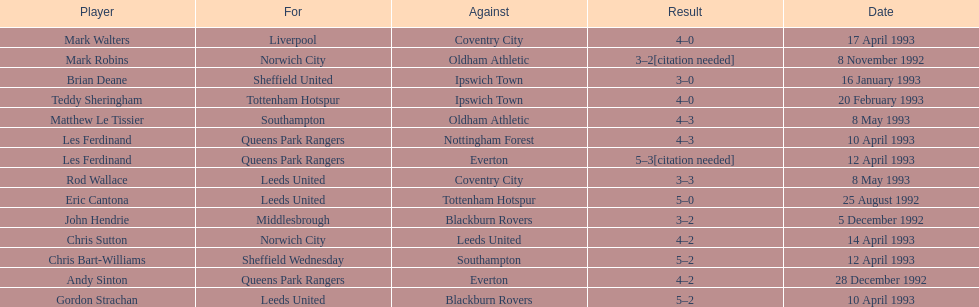Southampton played on may 8th, 1993, who was their opponent? Oldham Athletic. 